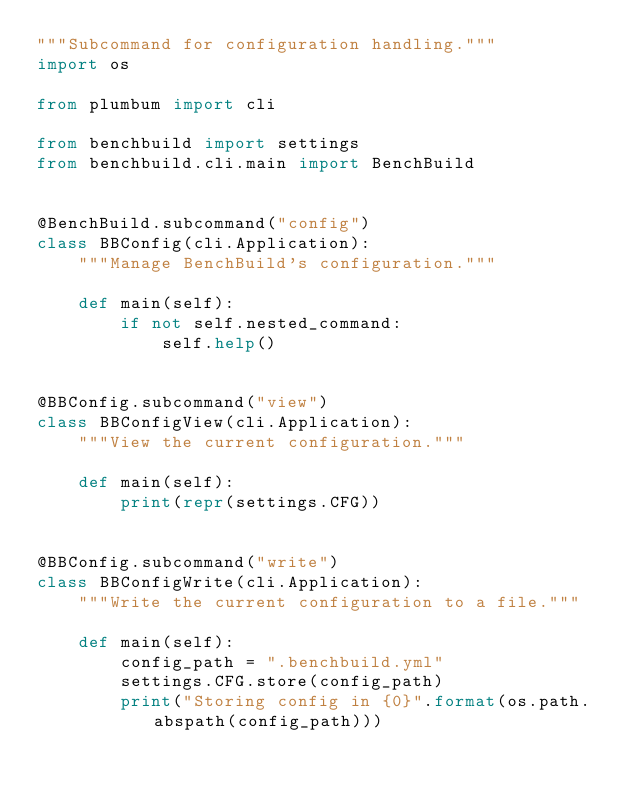Convert code to text. <code><loc_0><loc_0><loc_500><loc_500><_Python_>"""Subcommand for configuration handling."""
import os

from plumbum import cli

from benchbuild import settings
from benchbuild.cli.main import BenchBuild


@BenchBuild.subcommand("config")
class BBConfig(cli.Application):
    """Manage BenchBuild's configuration."""

    def main(self):
        if not self.nested_command:
            self.help()


@BBConfig.subcommand("view")
class BBConfigView(cli.Application):
    """View the current configuration."""

    def main(self):
        print(repr(settings.CFG))


@BBConfig.subcommand("write")
class BBConfigWrite(cli.Application):
    """Write the current configuration to a file."""

    def main(self):
        config_path = ".benchbuild.yml"
        settings.CFG.store(config_path)
        print("Storing config in {0}".format(os.path.abspath(config_path)))
</code> 